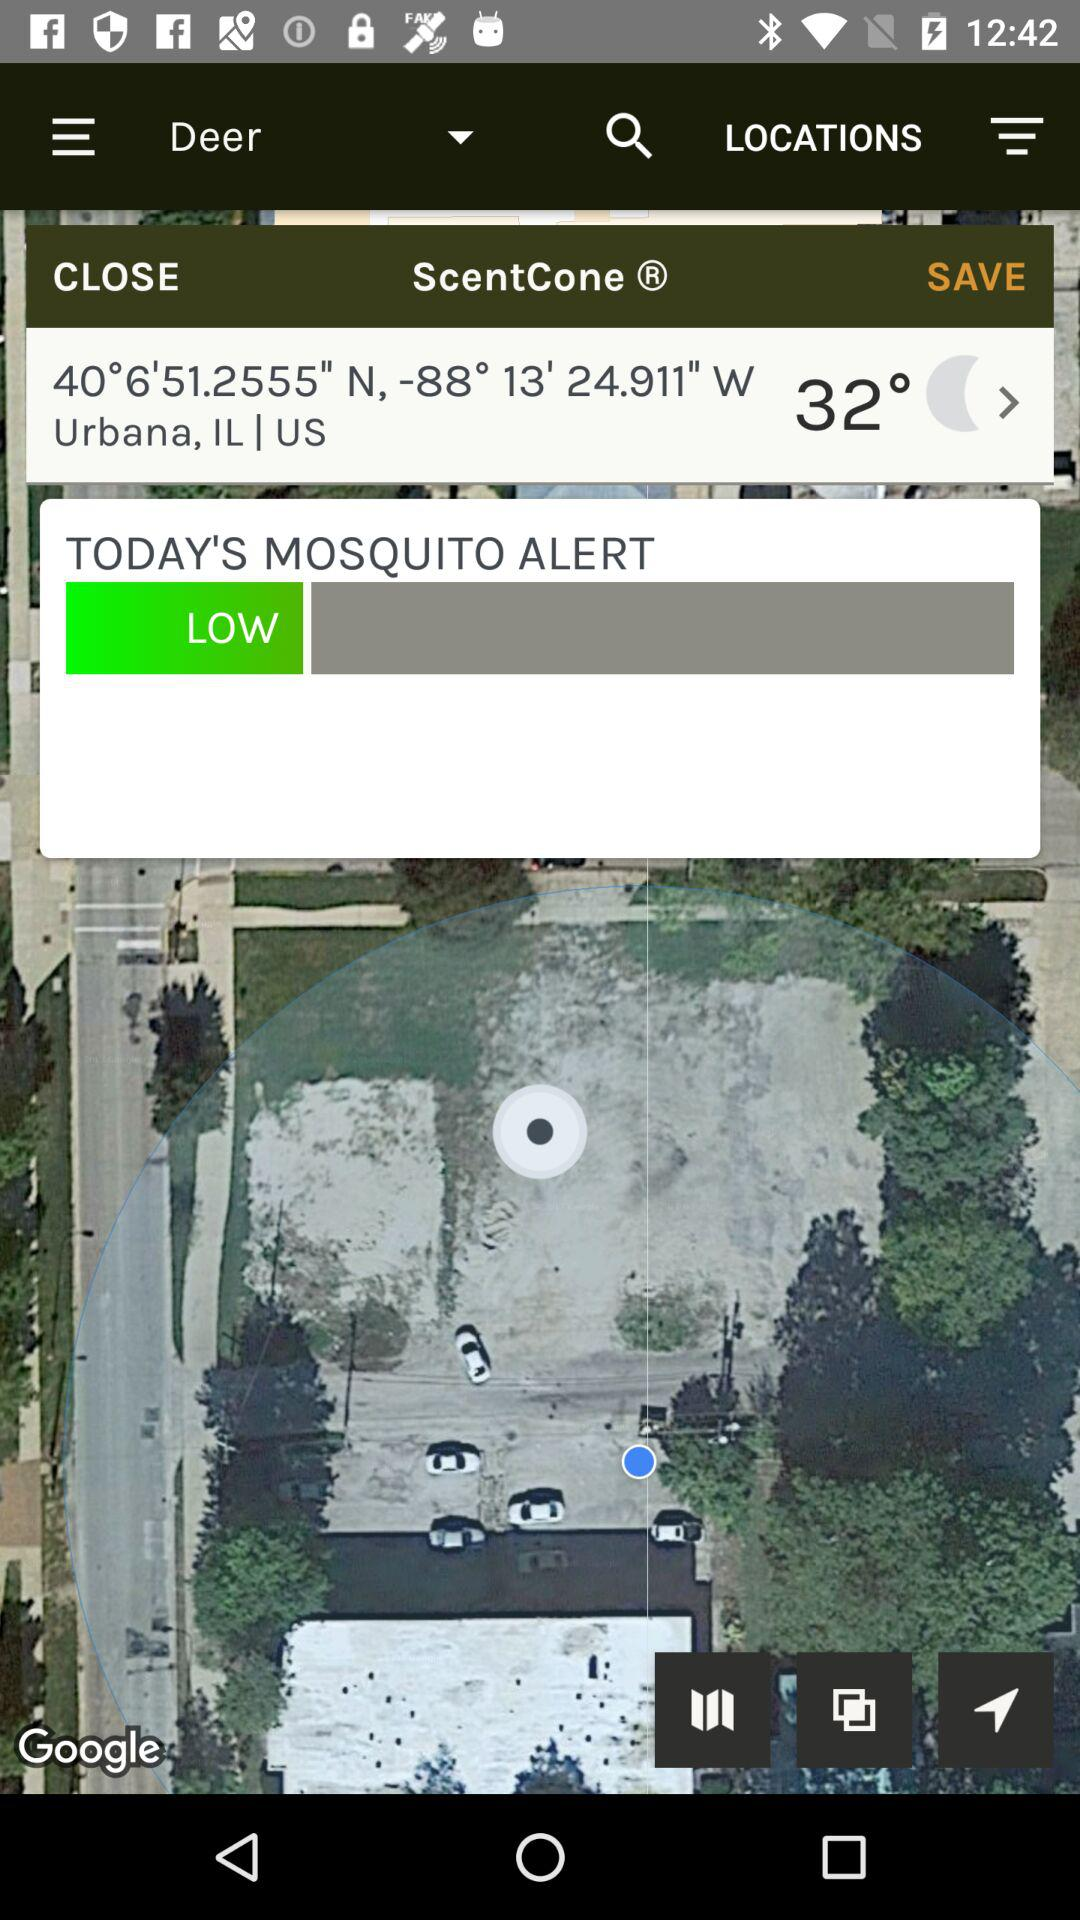What is the temperature? The temperature is 32°. 